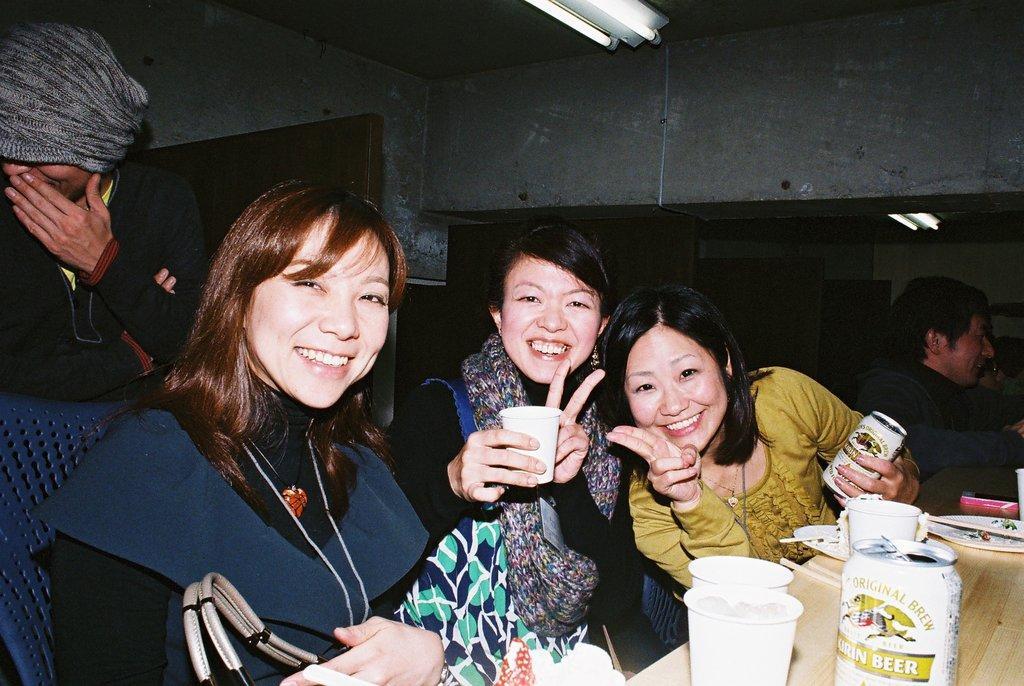Please provide a concise description of this image. Here in this picture we can see a group of women sitting on a place with a table in front of them having cups, tins and plates present and we can see all of them are smiling and behind them also we can see other people standing and sitting over there and on the wall we can see a mirror present and on the roof we can see lights present. 